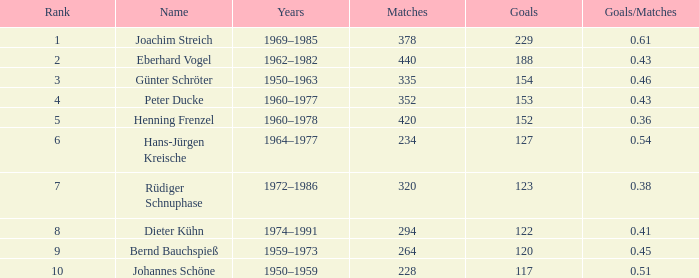What are the minimum objectives that have goals/games higher than None. 